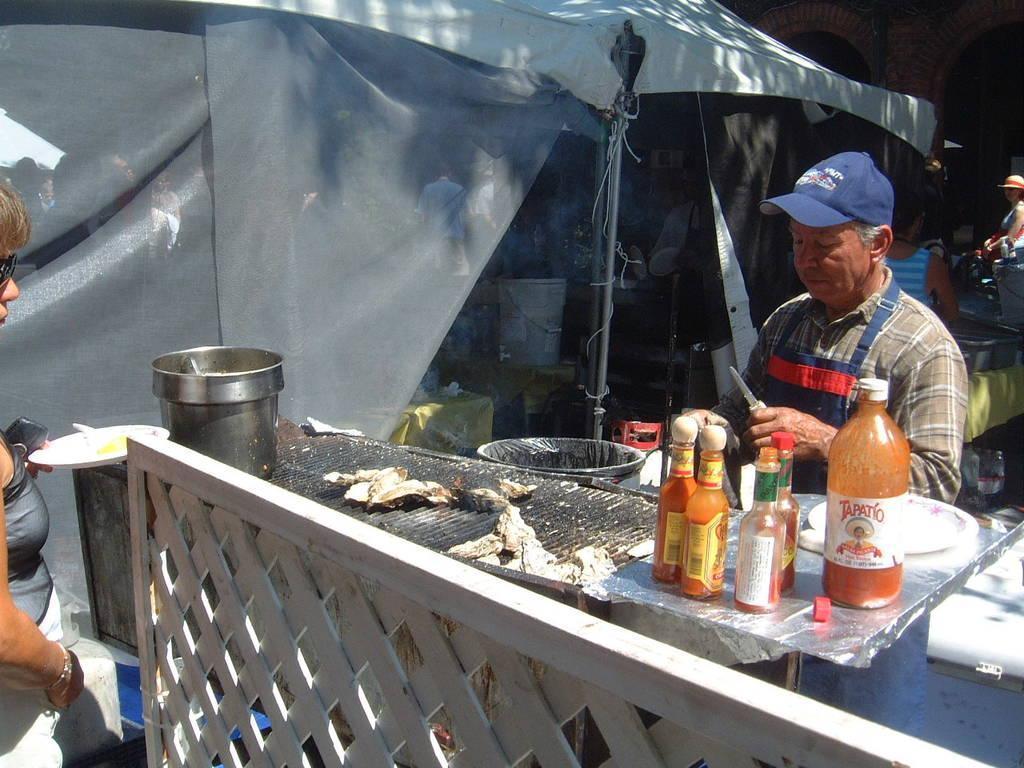Can you describe this image briefly? In this picture we can see bottles, bowl, plates, bucket, tent, poles, caps, goggles, table and some objects and some people and in the background we can see arches. 